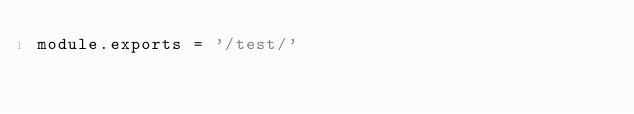Convert code to text. <code><loc_0><loc_0><loc_500><loc_500><_JavaScript_>module.exports = '/test/'
</code> 